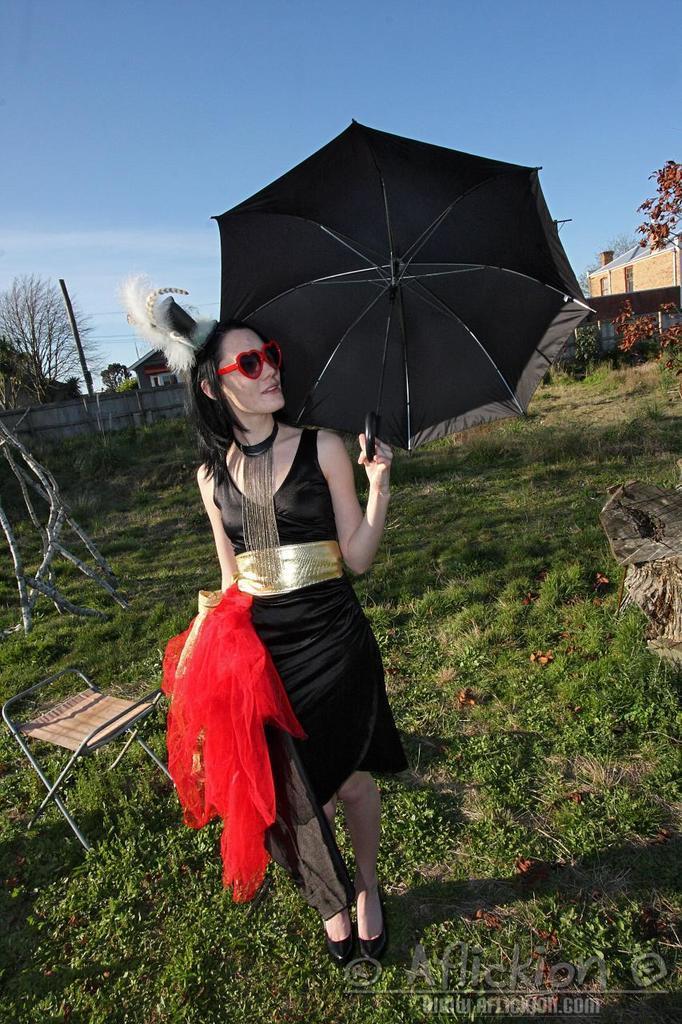Can you describe this image briefly? In this image there is a girl standing on the ground by holding the black colour umbrella. In the background there is a building on the right side. On the ground there is grass and some small plants. At the top there is sky. On the left side there is a wooden fence at the back side. At the bottom there is a stool beside the girl. The girl is wearing the black colour costume. 